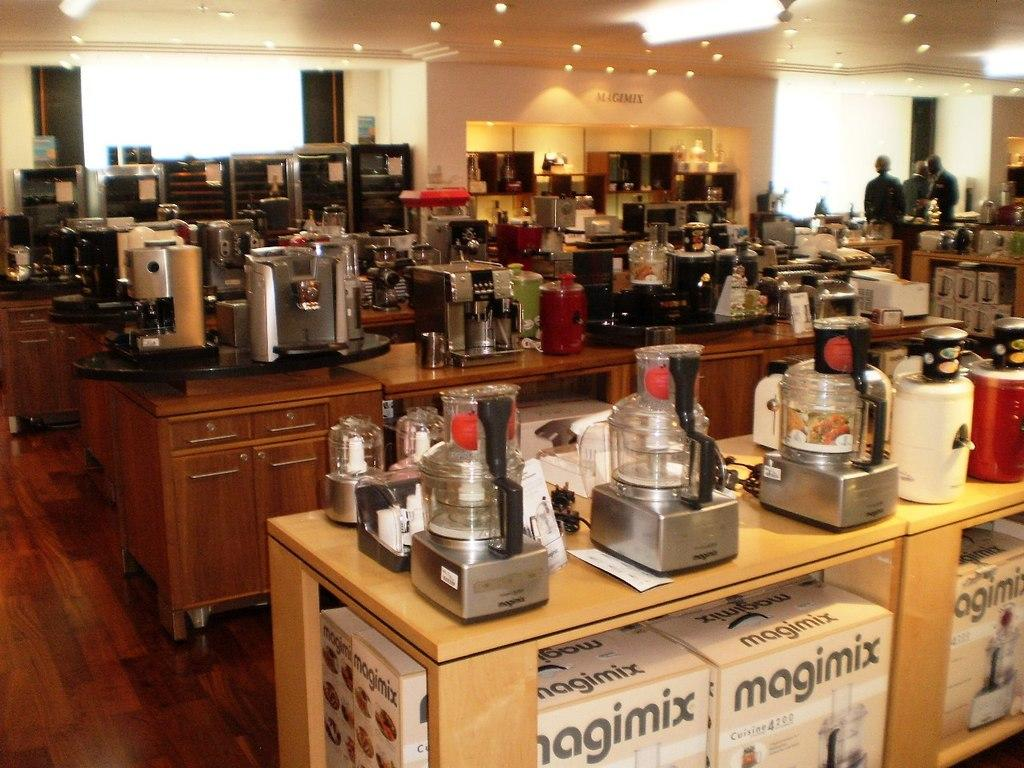<image>
Describe the image concisely. Boxes of magimix food processors are stocked on the shelves. 